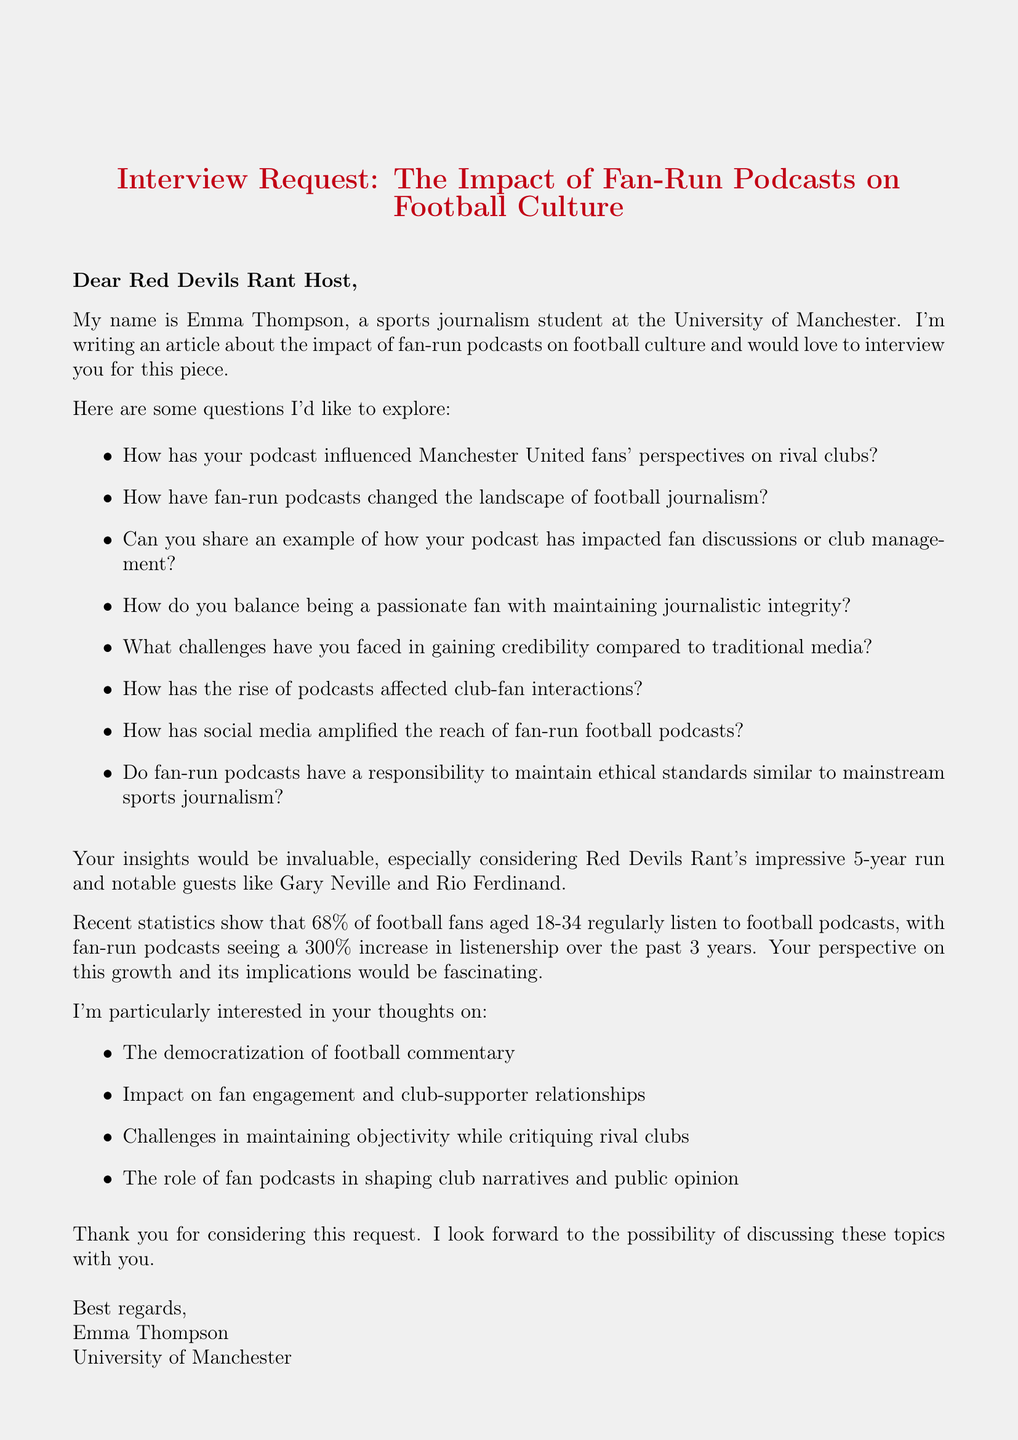What is the name of the podcast? The podcast name is mentioned at the beginning of the document as "Red Devils Rant."
Answer: Red Devils Rant Who is the interviewer? The interviewer's name is given at the start of the email as "Emma Thompson."
Answer: Emma Thompson How many years has the podcast been running? The document states that the podcast has been running for 5 years.
Answer: 5 What is the weekly audience size of the podcast? The document indicates that the podcast has an audience size of "250,000 weekly listeners."
Answer: 250,000 weekly listeners What percentage of football fans aged 18-34 listen to football podcasts? The document provides the statistic that "68% of football fans aged 18-34 regularly listen to football podcasts."
Answer: 68% How much has listenership increased for fan-run football podcasts? According to the document, fan-run football podcasts have seen a "300% increase in listenership over the past 3 years."
Answer: 300% What topic regarding fan engagement is mentioned in the key topics list? The document lists "Impact on fan engagement and club-supporter relationships" as one of the key topics.
Answer: Impact on fan engagement and club-supporter relationships Who are some notable guests of the podcast? The document lists notable guests, including "Gary Neville, Rio Ferdinand, Peter Schmeichel."
Answer: Gary Neville, Rio Ferdinand, Peter Schmeichel 